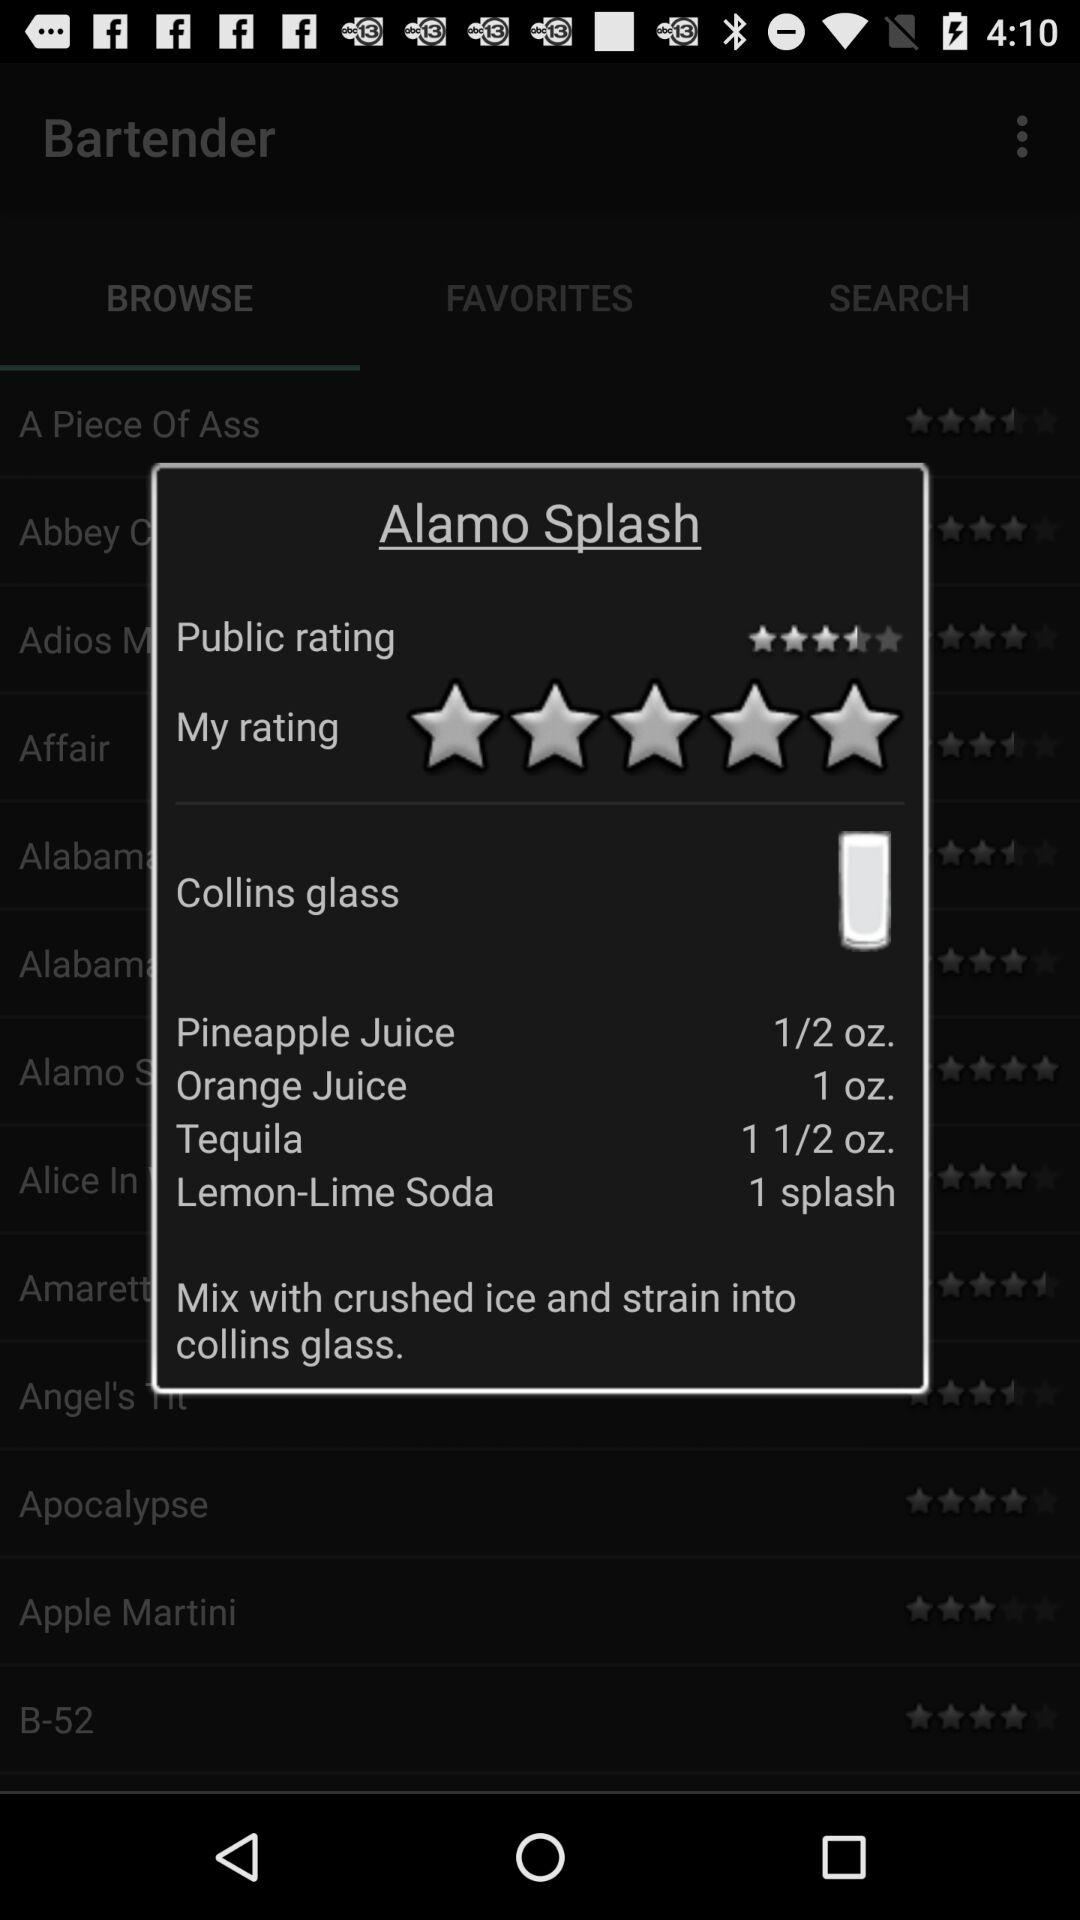How many ingredients are in the Alamo Splash recipe?
Answer the question using a single word or phrase. 4 